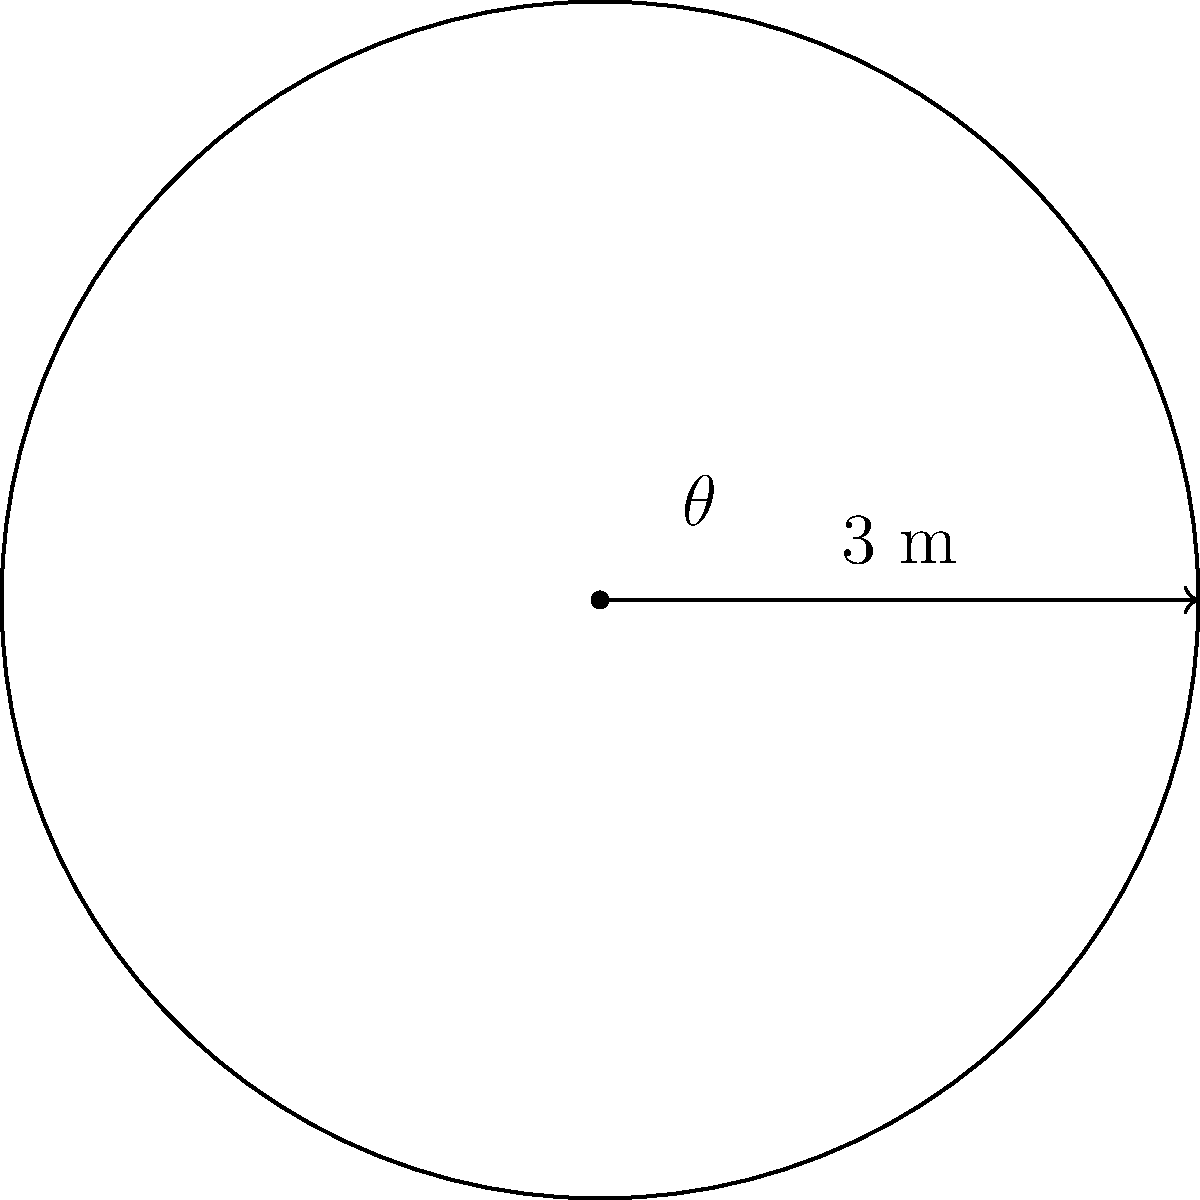As a chef planning a unique dining experience, you're arranging a circular table with a radius of 3 meters. Using polar coordinates, calculate the area of the table to determine how many guests can be comfortably seated. Round your answer to the nearest square meter. To solve this problem, we'll use the formula for the area of a circle in polar coordinates:

1) The formula for the area of a region in polar coordinates is:
   $$A = \frac{1}{2} \int_{0}^{2\pi} r^2(\theta) d\theta$$

2) In this case, $r(\theta) = 3$ (constant radius of 3 meters)

3) Substituting this into our formula:
   $$A = \frac{1}{2} \int_{0}^{2\pi} 3^2 d\theta$$

4) Simplify:
   $$A = \frac{1}{2} \int_{0}^{2\pi} 9 d\theta$$

5) Integrate:
   $$A = \frac{1}{2} \cdot 9 \cdot \theta \bigg|_{0}^{2\pi}$$

6) Evaluate:
   $$A = \frac{1}{2} \cdot 9 \cdot 2\pi = 9\pi$$

7) Calculate and round to the nearest square meter:
   $$A \approx 28.27 \approx 28 \text{ m}^2$$
Answer: 28 m² 